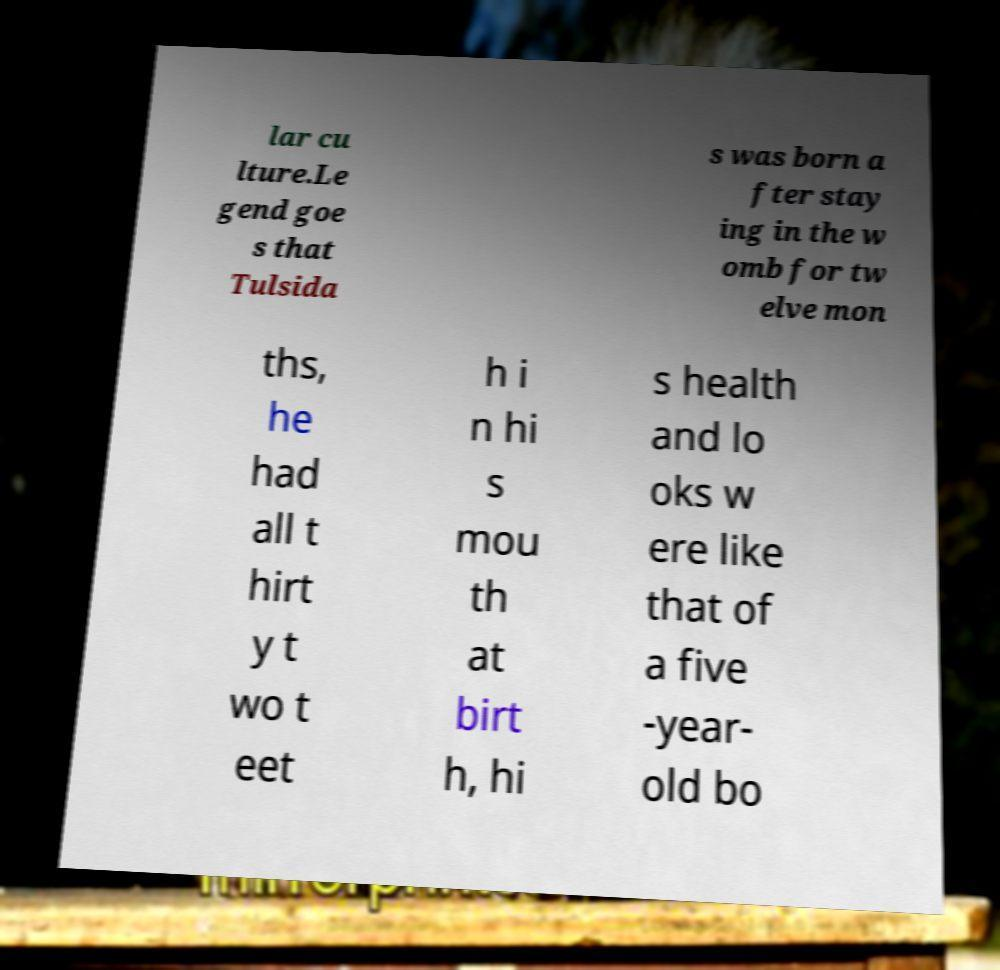There's text embedded in this image that I need extracted. Can you transcribe it verbatim? lar cu lture.Le gend goe s that Tulsida s was born a fter stay ing in the w omb for tw elve mon ths, he had all t hirt y t wo t eet h i n hi s mou th at birt h, hi s health and lo oks w ere like that of a five -year- old bo 